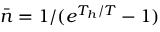<formula> <loc_0><loc_0><loc_500><loc_500>\bar { n } = 1 / ( e ^ { T _ { h } / T } - 1 )</formula> 